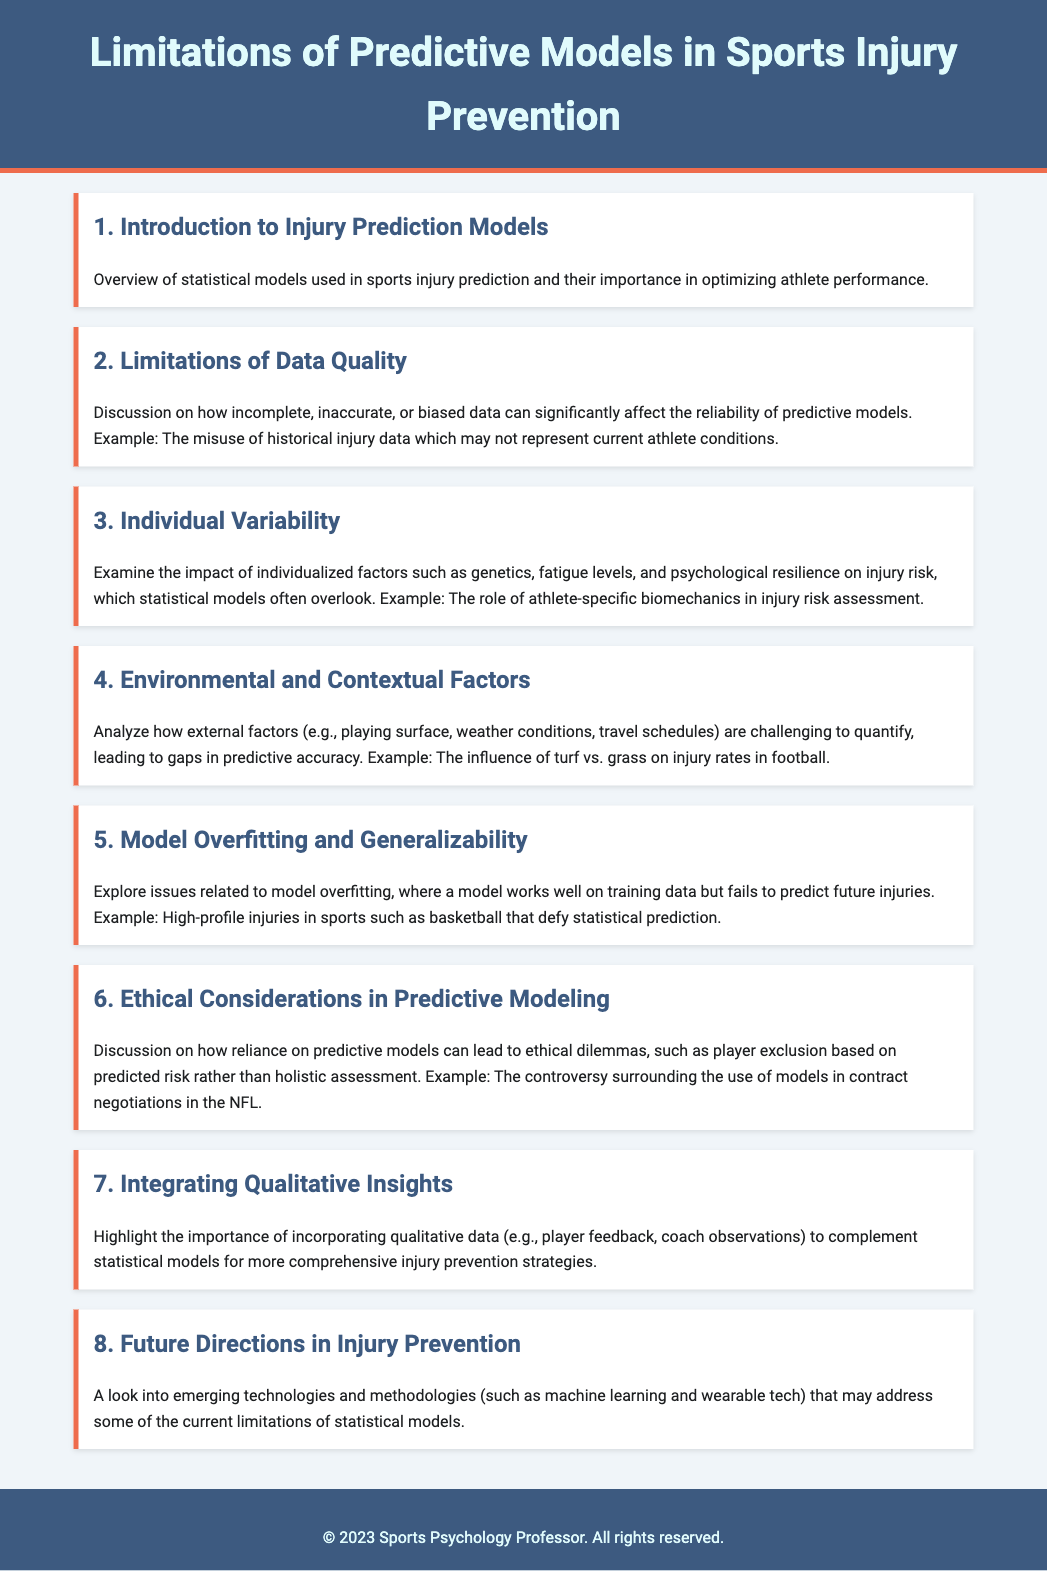What is the title of the document? The title is stated in the header of the document.
Answer: Limitations of Predictive Models in Sports Injury Prevention What is the first agenda item? The agenda items are numbered, and the first one is specified in the document.
Answer: Introduction to Injury Prediction Models How many agenda items are there in total? The number of agenda items is counted from the list provided in the document.
Answer: Eight What is discussed in the second agenda item? The second agenda item includes a brief description of its content.
Answer: Limitations of Data Quality What example is given related to model overfitting? The document provides specific examples for various agenda items, including the one for model overfitting.
Answer: High-profile injuries in sports such as basketball What factor is mentioned that statistical models often overlook? The agenda item highlights individual factors that predictive models may ignore.
Answer: Psychological resilience Which agenda item addresses ethical considerations? The document lists agenda items that focus on different topics, including ethics.
Answer: Ethical Considerations in Predictive Modeling What emerging technologies are mentioned in the future directions agenda item? The last agenda item points to new methodologies that could help overcome current model limitations.
Answer: Machine learning and wearable tech 